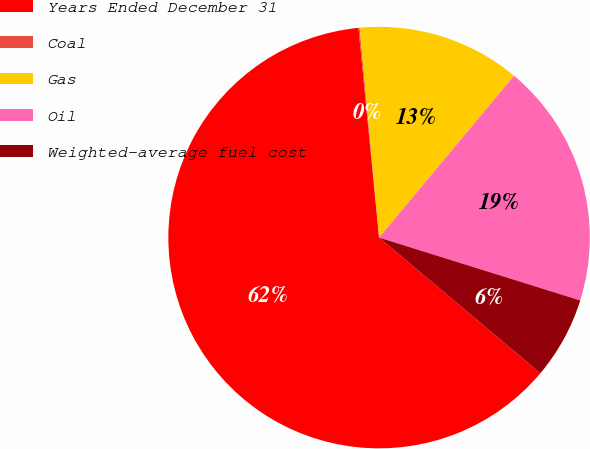Convert chart. <chart><loc_0><loc_0><loc_500><loc_500><pie_chart><fcel>Years Ended December 31<fcel>Coal<fcel>Gas<fcel>Oil<fcel>Weighted-average fuel cost<nl><fcel>62.31%<fcel>0.09%<fcel>12.53%<fcel>18.76%<fcel>6.31%<nl></chart> 